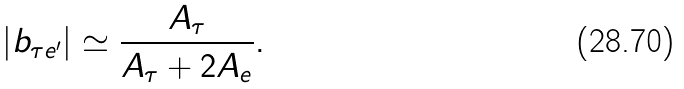Convert formula to latex. <formula><loc_0><loc_0><loc_500><loc_500>| b _ { \tau e ^ { \prime } } | \simeq { \frac { A _ { \tau } } { A _ { \tau } + 2 A _ { e } } } .</formula> 